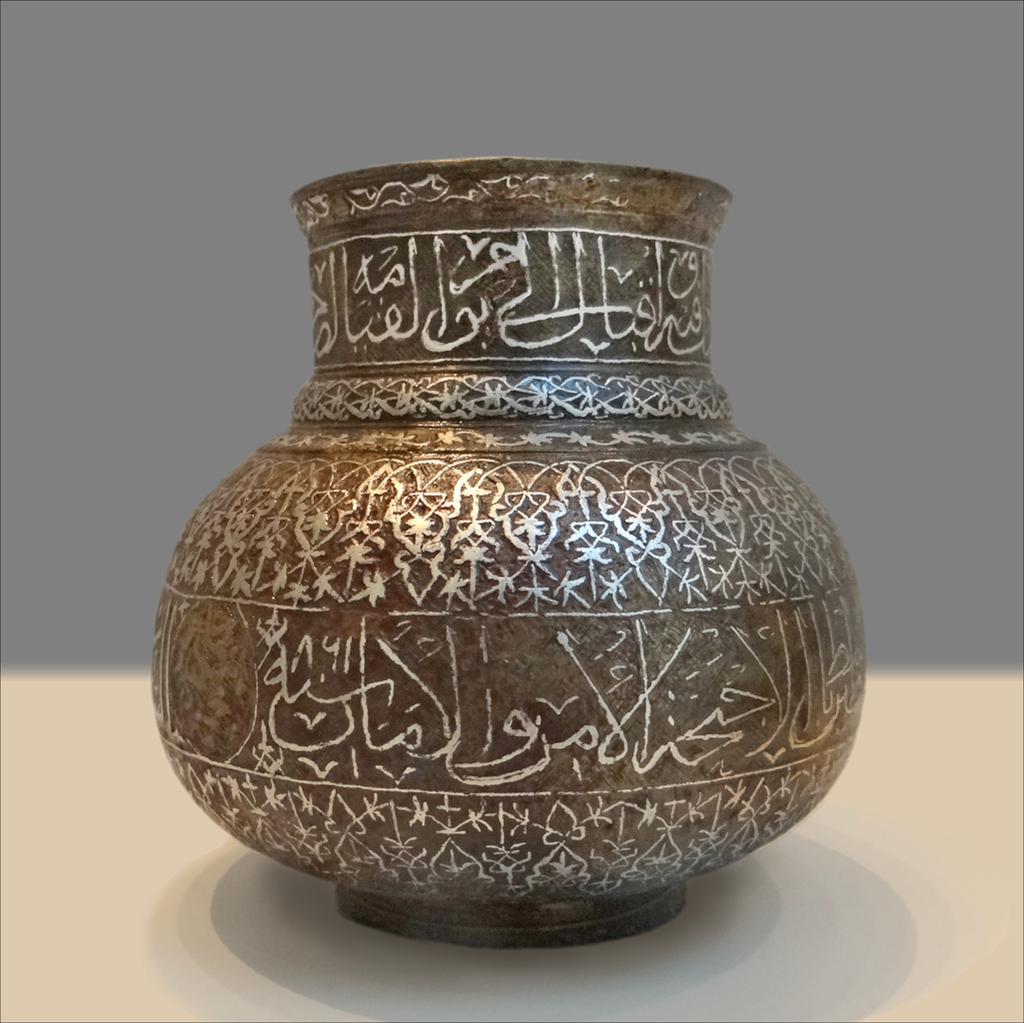What object is the main focus of the image? There is a pot in the image. What can be observed on the surface of the pot? The pot has texts and designs on it. How is the pot positioned in the image? The pot is on a platform. What color is predominant in the background of the image? The background of the image has a violet color. How many sticks are used to increase the height of the pot in the image? There are no sticks present in the image, and the height of the pot is not being increased. 